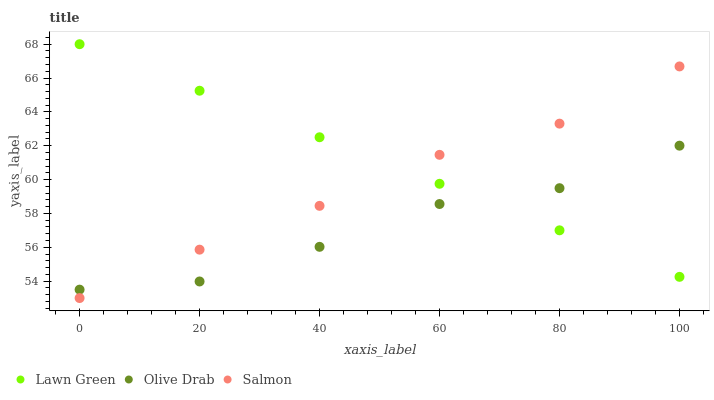Does Olive Drab have the minimum area under the curve?
Answer yes or no. Yes. Does Lawn Green have the maximum area under the curve?
Answer yes or no. Yes. Does Salmon have the minimum area under the curve?
Answer yes or no. No. Does Salmon have the maximum area under the curve?
Answer yes or no. No. Is Lawn Green the smoothest?
Answer yes or no. Yes. Is Olive Drab the roughest?
Answer yes or no. Yes. Is Salmon the smoothest?
Answer yes or no. No. Is Salmon the roughest?
Answer yes or no. No. Does Salmon have the lowest value?
Answer yes or no. Yes. Does Olive Drab have the lowest value?
Answer yes or no. No. Does Lawn Green have the highest value?
Answer yes or no. Yes. Does Salmon have the highest value?
Answer yes or no. No. Does Lawn Green intersect Salmon?
Answer yes or no. Yes. Is Lawn Green less than Salmon?
Answer yes or no. No. Is Lawn Green greater than Salmon?
Answer yes or no. No. 